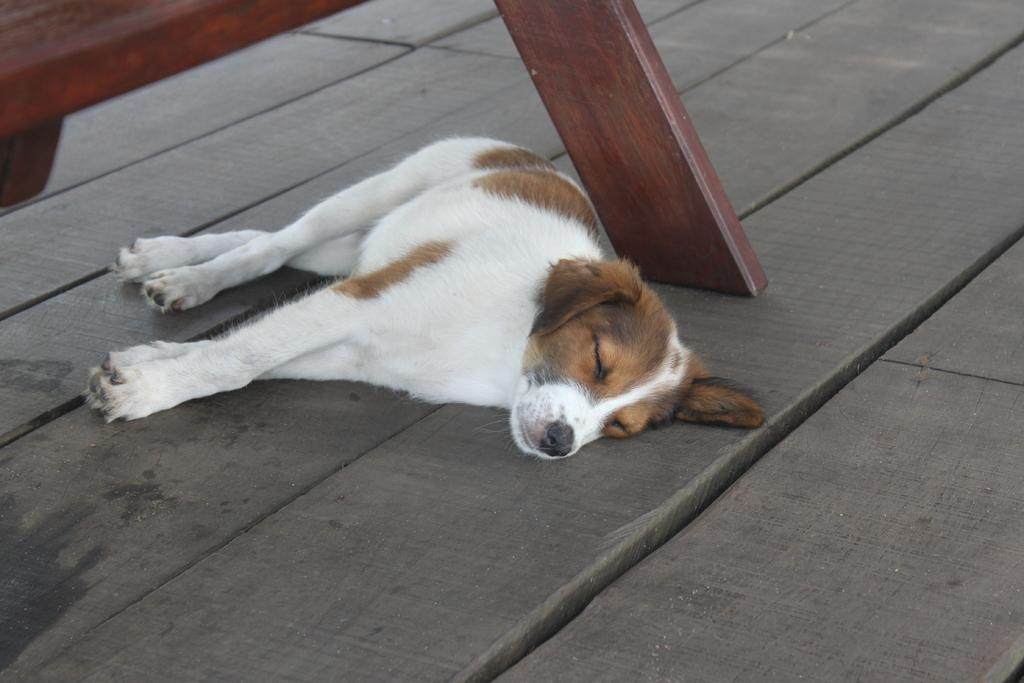What type of animal is present in the image? There is a dog in the image. What is the dog's position in the image? The dog is lying on the floor. Can you describe the wooden object in the image? Unfortunately, there is not enough information provided about the wooden object to describe it. What type of vessel is the dog using to control the fowl in the image? There is no vessel, control, or fowl present in the image. 